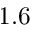Convert formula to latex. <formula><loc_0><loc_0><loc_500><loc_500>1 . 6</formula> 